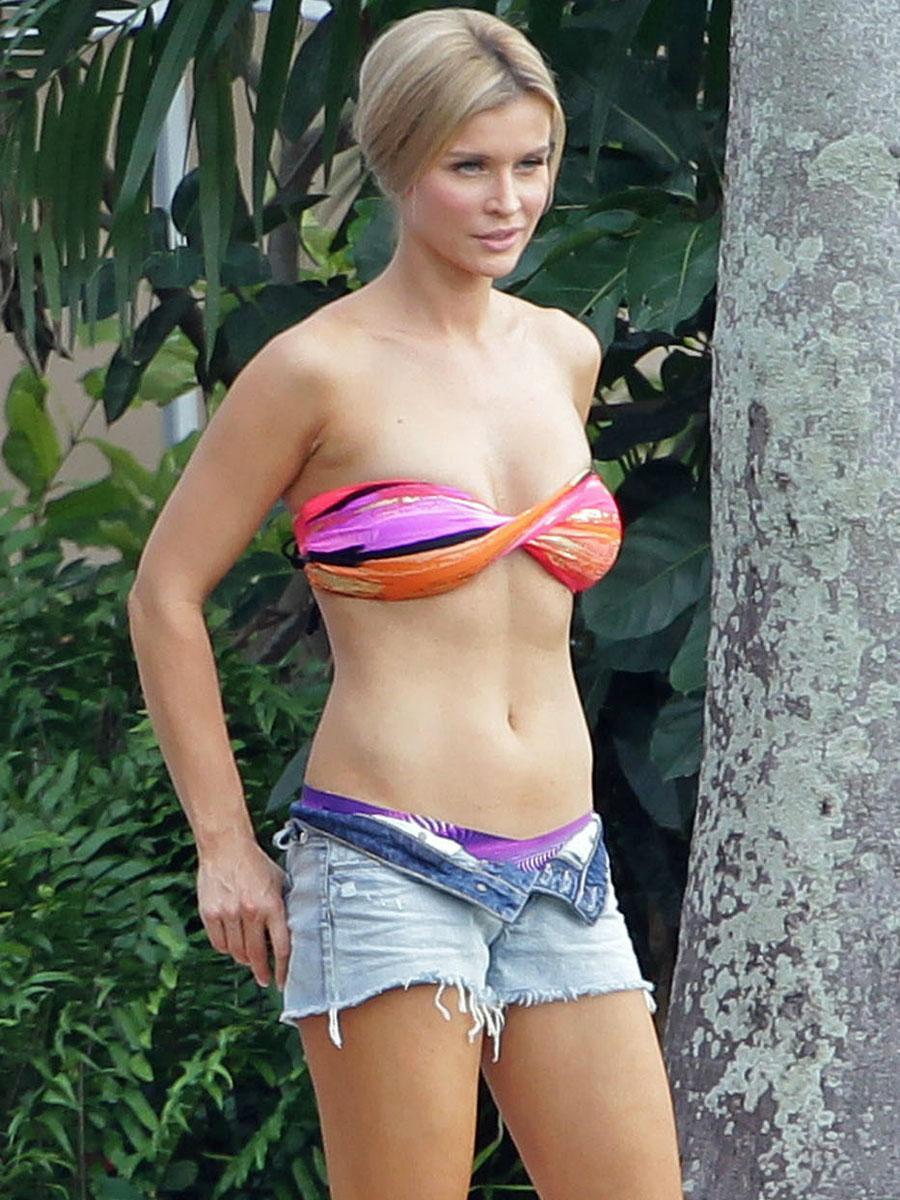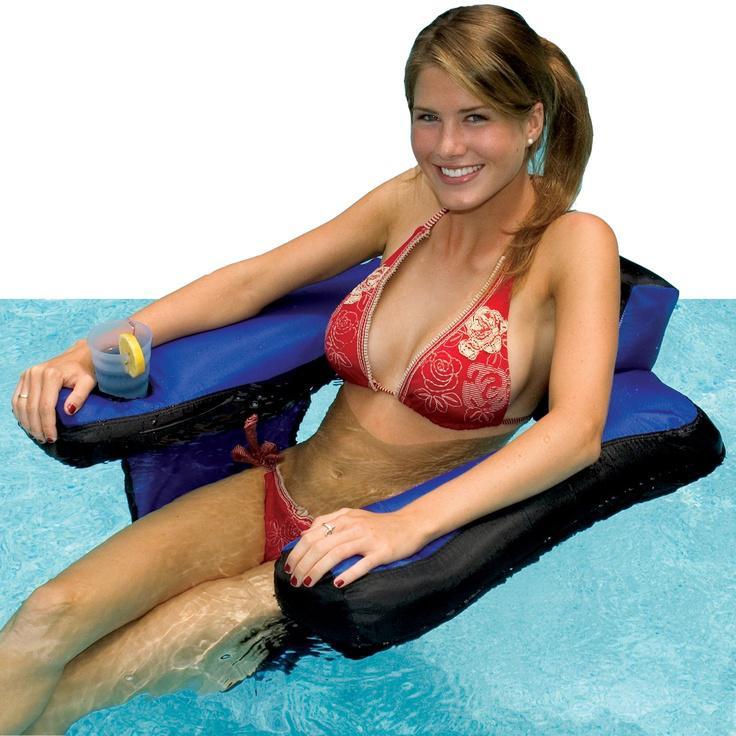The first image is the image on the left, the second image is the image on the right. Evaluate the accuracy of this statement regarding the images: "An image shows one model wearing a twisted bikini top and denim shorts.". Is it true? Answer yes or no. Yes. The first image is the image on the left, the second image is the image on the right. Assess this claim about the two images: "A woman is wearing a predominantly orange swimsuit and denim shorts.". Correct or not? Answer yes or no. Yes. 